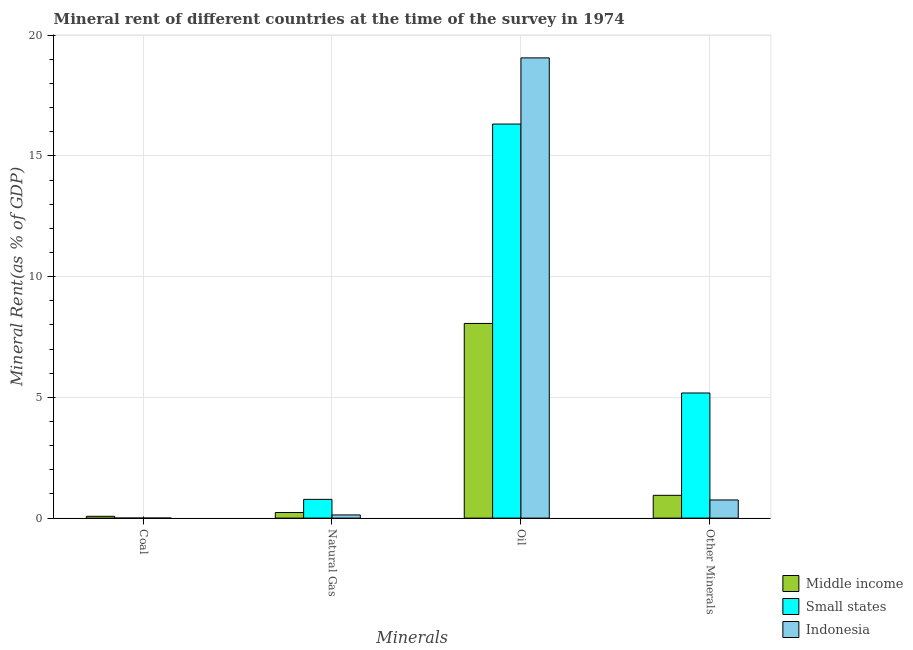How many groups of bars are there?
Your answer should be compact. 4. Are the number of bars per tick equal to the number of legend labels?
Your answer should be compact. Yes. Are the number of bars on each tick of the X-axis equal?
Your answer should be very brief. Yes. How many bars are there on the 2nd tick from the left?
Your answer should be compact. 3. How many bars are there on the 1st tick from the right?
Provide a short and direct response. 3. What is the label of the 1st group of bars from the left?
Offer a terse response. Coal. What is the  rent of other minerals in Indonesia?
Your response must be concise. 0.75. Across all countries, what is the maximum coal rent?
Provide a succinct answer. 0.08. Across all countries, what is the minimum natural gas rent?
Your answer should be very brief. 0.13. What is the total oil rent in the graph?
Keep it short and to the point. 43.45. What is the difference between the natural gas rent in Indonesia and that in Middle income?
Make the answer very short. -0.1. What is the difference between the oil rent in Indonesia and the coal rent in Middle income?
Provide a short and direct response. 18.99. What is the average oil rent per country?
Offer a very short reply. 14.48. What is the difference between the coal rent and oil rent in Middle income?
Provide a succinct answer. -7.99. In how many countries, is the natural gas rent greater than 9 %?
Keep it short and to the point. 0. What is the ratio of the oil rent in Small states to that in Indonesia?
Offer a terse response. 0.86. Is the natural gas rent in Small states less than that in Indonesia?
Your answer should be very brief. No. What is the difference between the highest and the second highest natural gas rent?
Provide a short and direct response. 0.54. What is the difference between the highest and the lowest coal rent?
Offer a very short reply. 0.07. Is the sum of the coal rent in Indonesia and Small states greater than the maximum oil rent across all countries?
Provide a succinct answer. No. Is it the case that in every country, the sum of the natural gas rent and oil rent is greater than the sum of  rent of other minerals and coal rent?
Offer a terse response. Yes. What does the 3rd bar from the left in Oil represents?
Offer a terse response. Indonesia. What does the 1st bar from the right in Natural Gas represents?
Make the answer very short. Indonesia. Is it the case that in every country, the sum of the coal rent and natural gas rent is greater than the oil rent?
Your response must be concise. No. How many bars are there?
Give a very brief answer. 12. Are all the bars in the graph horizontal?
Provide a short and direct response. No. How many countries are there in the graph?
Offer a terse response. 3. Does the graph contain grids?
Ensure brevity in your answer.  Yes. How many legend labels are there?
Offer a terse response. 3. What is the title of the graph?
Keep it short and to the point. Mineral rent of different countries at the time of the survey in 1974. What is the label or title of the X-axis?
Provide a short and direct response. Minerals. What is the label or title of the Y-axis?
Your answer should be very brief. Mineral Rent(as % of GDP). What is the Mineral Rent(as % of GDP) of Middle income in Coal?
Ensure brevity in your answer.  0.08. What is the Mineral Rent(as % of GDP) of Small states in Coal?
Your answer should be very brief. 0. What is the Mineral Rent(as % of GDP) in Indonesia in Coal?
Offer a very short reply. 0. What is the Mineral Rent(as % of GDP) in Middle income in Natural Gas?
Give a very brief answer. 0.23. What is the Mineral Rent(as % of GDP) of Small states in Natural Gas?
Make the answer very short. 0.78. What is the Mineral Rent(as % of GDP) in Indonesia in Natural Gas?
Your response must be concise. 0.13. What is the Mineral Rent(as % of GDP) in Middle income in Oil?
Offer a terse response. 8.06. What is the Mineral Rent(as % of GDP) in Small states in Oil?
Provide a short and direct response. 16.32. What is the Mineral Rent(as % of GDP) in Indonesia in Oil?
Give a very brief answer. 19.06. What is the Mineral Rent(as % of GDP) of Middle income in Other Minerals?
Offer a very short reply. 0.94. What is the Mineral Rent(as % of GDP) of Small states in Other Minerals?
Provide a short and direct response. 5.18. What is the Mineral Rent(as % of GDP) in Indonesia in Other Minerals?
Your answer should be compact. 0.75. Across all Minerals, what is the maximum Mineral Rent(as % of GDP) of Middle income?
Your response must be concise. 8.06. Across all Minerals, what is the maximum Mineral Rent(as % of GDP) of Small states?
Your response must be concise. 16.32. Across all Minerals, what is the maximum Mineral Rent(as % of GDP) of Indonesia?
Keep it short and to the point. 19.06. Across all Minerals, what is the minimum Mineral Rent(as % of GDP) in Middle income?
Offer a terse response. 0.08. Across all Minerals, what is the minimum Mineral Rent(as % of GDP) of Small states?
Your response must be concise. 0. Across all Minerals, what is the minimum Mineral Rent(as % of GDP) of Indonesia?
Provide a short and direct response. 0. What is the total Mineral Rent(as % of GDP) in Middle income in the graph?
Give a very brief answer. 9.31. What is the total Mineral Rent(as % of GDP) in Small states in the graph?
Provide a short and direct response. 22.28. What is the total Mineral Rent(as % of GDP) in Indonesia in the graph?
Offer a terse response. 19.95. What is the difference between the Mineral Rent(as % of GDP) in Middle income in Coal and that in Natural Gas?
Provide a short and direct response. -0.16. What is the difference between the Mineral Rent(as % of GDP) of Small states in Coal and that in Natural Gas?
Give a very brief answer. -0.78. What is the difference between the Mineral Rent(as % of GDP) in Indonesia in Coal and that in Natural Gas?
Your answer should be very brief. -0.13. What is the difference between the Mineral Rent(as % of GDP) in Middle income in Coal and that in Oil?
Your answer should be compact. -7.99. What is the difference between the Mineral Rent(as % of GDP) of Small states in Coal and that in Oil?
Provide a short and direct response. -16.32. What is the difference between the Mineral Rent(as % of GDP) in Indonesia in Coal and that in Oil?
Provide a succinct answer. -19.06. What is the difference between the Mineral Rent(as % of GDP) of Middle income in Coal and that in Other Minerals?
Make the answer very short. -0.87. What is the difference between the Mineral Rent(as % of GDP) of Small states in Coal and that in Other Minerals?
Offer a terse response. -5.18. What is the difference between the Mineral Rent(as % of GDP) in Indonesia in Coal and that in Other Minerals?
Give a very brief answer. -0.75. What is the difference between the Mineral Rent(as % of GDP) of Middle income in Natural Gas and that in Oil?
Keep it short and to the point. -7.83. What is the difference between the Mineral Rent(as % of GDP) of Small states in Natural Gas and that in Oil?
Give a very brief answer. -15.54. What is the difference between the Mineral Rent(as % of GDP) of Indonesia in Natural Gas and that in Oil?
Provide a succinct answer. -18.93. What is the difference between the Mineral Rent(as % of GDP) in Middle income in Natural Gas and that in Other Minerals?
Give a very brief answer. -0.71. What is the difference between the Mineral Rent(as % of GDP) in Small states in Natural Gas and that in Other Minerals?
Offer a very short reply. -4.41. What is the difference between the Mineral Rent(as % of GDP) of Indonesia in Natural Gas and that in Other Minerals?
Your answer should be very brief. -0.62. What is the difference between the Mineral Rent(as % of GDP) of Middle income in Oil and that in Other Minerals?
Provide a succinct answer. 7.12. What is the difference between the Mineral Rent(as % of GDP) in Small states in Oil and that in Other Minerals?
Provide a short and direct response. 11.14. What is the difference between the Mineral Rent(as % of GDP) of Indonesia in Oil and that in Other Minerals?
Your answer should be very brief. 18.31. What is the difference between the Mineral Rent(as % of GDP) in Middle income in Coal and the Mineral Rent(as % of GDP) in Small states in Natural Gas?
Your answer should be compact. -0.7. What is the difference between the Mineral Rent(as % of GDP) of Middle income in Coal and the Mineral Rent(as % of GDP) of Indonesia in Natural Gas?
Your answer should be compact. -0.06. What is the difference between the Mineral Rent(as % of GDP) of Small states in Coal and the Mineral Rent(as % of GDP) of Indonesia in Natural Gas?
Provide a succinct answer. -0.13. What is the difference between the Mineral Rent(as % of GDP) of Middle income in Coal and the Mineral Rent(as % of GDP) of Small states in Oil?
Your answer should be compact. -16.25. What is the difference between the Mineral Rent(as % of GDP) of Middle income in Coal and the Mineral Rent(as % of GDP) of Indonesia in Oil?
Your answer should be compact. -18.99. What is the difference between the Mineral Rent(as % of GDP) in Small states in Coal and the Mineral Rent(as % of GDP) in Indonesia in Oil?
Your answer should be very brief. -19.06. What is the difference between the Mineral Rent(as % of GDP) of Middle income in Coal and the Mineral Rent(as % of GDP) of Small states in Other Minerals?
Your answer should be very brief. -5.11. What is the difference between the Mineral Rent(as % of GDP) of Middle income in Coal and the Mineral Rent(as % of GDP) of Indonesia in Other Minerals?
Provide a short and direct response. -0.68. What is the difference between the Mineral Rent(as % of GDP) of Small states in Coal and the Mineral Rent(as % of GDP) of Indonesia in Other Minerals?
Offer a terse response. -0.75. What is the difference between the Mineral Rent(as % of GDP) in Middle income in Natural Gas and the Mineral Rent(as % of GDP) in Small states in Oil?
Ensure brevity in your answer.  -16.09. What is the difference between the Mineral Rent(as % of GDP) of Middle income in Natural Gas and the Mineral Rent(as % of GDP) of Indonesia in Oil?
Your answer should be very brief. -18.83. What is the difference between the Mineral Rent(as % of GDP) of Small states in Natural Gas and the Mineral Rent(as % of GDP) of Indonesia in Oil?
Your answer should be compact. -18.29. What is the difference between the Mineral Rent(as % of GDP) in Middle income in Natural Gas and the Mineral Rent(as % of GDP) in Small states in Other Minerals?
Your answer should be compact. -4.95. What is the difference between the Mineral Rent(as % of GDP) in Middle income in Natural Gas and the Mineral Rent(as % of GDP) in Indonesia in Other Minerals?
Your answer should be compact. -0.52. What is the difference between the Mineral Rent(as % of GDP) in Small states in Natural Gas and the Mineral Rent(as % of GDP) in Indonesia in Other Minerals?
Offer a terse response. 0.02. What is the difference between the Mineral Rent(as % of GDP) in Middle income in Oil and the Mineral Rent(as % of GDP) in Small states in Other Minerals?
Give a very brief answer. 2.88. What is the difference between the Mineral Rent(as % of GDP) in Middle income in Oil and the Mineral Rent(as % of GDP) in Indonesia in Other Minerals?
Keep it short and to the point. 7.31. What is the difference between the Mineral Rent(as % of GDP) of Small states in Oil and the Mineral Rent(as % of GDP) of Indonesia in Other Minerals?
Your answer should be compact. 15.57. What is the average Mineral Rent(as % of GDP) in Middle income per Minerals?
Offer a very short reply. 2.33. What is the average Mineral Rent(as % of GDP) of Small states per Minerals?
Offer a terse response. 5.57. What is the average Mineral Rent(as % of GDP) of Indonesia per Minerals?
Ensure brevity in your answer.  4.99. What is the difference between the Mineral Rent(as % of GDP) of Middle income and Mineral Rent(as % of GDP) of Small states in Coal?
Provide a short and direct response. 0.07. What is the difference between the Mineral Rent(as % of GDP) in Middle income and Mineral Rent(as % of GDP) in Indonesia in Coal?
Offer a very short reply. 0.07. What is the difference between the Mineral Rent(as % of GDP) of Small states and Mineral Rent(as % of GDP) of Indonesia in Coal?
Give a very brief answer. -0. What is the difference between the Mineral Rent(as % of GDP) of Middle income and Mineral Rent(as % of GDP) of Small states in Natural Gas?
Ensure brevity in your answer.  -0.54. What is the difference between the Mineral Rent(as % of GDP) of Middle income and Mineral Rent(as % of GDP) of Indonesia in Natural Gas?
Your answer should be compact. 0.1. What is the difference between the Mineral Rent(as % of GDP) of Small states and Mineral Rent(as % of GDP) of Indonesia in Natural Gas?
Your answer should be compact. 0.64. What is the difference between the Mineral Rent(as % of GDP) in Middle income and Mineral Rent(as % of GDP) in Small states in Oil?
Your answer should be compact. -8.26. What is the difference between the Mineral Rent(as % of GDP) in Middle income and Mineral Rent(as % of GDP) in Indonesia in Oil?
Your response must be concise. -11. What is the difference between the Mineral Rent(as % of GDP) of Small states and Mineral Rent(as % of GDP) of Indonesia in Oil?
Provide a short and direct response. -2.74. What is the difference between the Mineral Rent(as % of GDP) of Middle income and Mineral Rent(as % of GDP) of Small states in Other Minerals?
Your answer should be very brief. -4.24. What is the difference between the Mineral Rent(as % of GDP) of Middle income and Mineral Rent(as % of GDP) of Indonesia in Other Minerals?
Your response must be concise. 0.19. What is the difference between the Mineral Rent(as % of GDP) of Small states and Mineral Rent(as % of GDP) of Indonesia in Other Minerals?
Offer a very short reply. 4.43. What is the ratio of the Mineral Rent(as % of GDP) of Middle income in Coal to that in Natural Gas?
Your response must be concise. 0.33. What is the ratio of the Mineral Rent(as % of GDP) of Small states in Coal to that in Natural Gas?
Provide a succinct answer. 0. What is the ratio of the Mineral Rent(as % of GDP) of Indonesia in Coal to that in Natural Gas?
Provide a short and direct response. 0.01. What is the ratio of the Mineral Rent(as % of GDP) of Middle income in Coal to that in Oil?
Give a very brief answer. 0.01. What is the ratio of the Mineral Rent(as % of GDP) of Indonesia in Coal to that in Oil?
Your answer should be compact. 0. What is the ratio of the Mineral Rent(as % of GDP) of Middle income in Coal to that in Other Minerals?
Offer a terse response. 0.08. What is the ratio of the Mineral Rent(as % of GDP) in Small states in Coal to that in Other Minerals?
Offer a very short reply. 0. What is the ratio of the Mineral Rent(as % of GDP) of Indonesia in Coal to that in Other Minerals?
Give a very brief answer. 0. What is the ratio of the Mineral Rent(as % of GDP) in Middle income in Natural Gas to that in Oil?
Make the answer very short. 0.03. What is the ratio of the Mineral Rent(as % of GDP) in Small states in Natural Gas to that in Oil?
Offer a terse response. 0.05. What is the ratio of the Mineral Rent(as % of GDP) of Indonesia in Natural Gas to that in Oil?
Provide a succinct answer. 0.01. What is the ratio of the Mineral Rent(as % of GDP) of Middle income in Natural Gas to that in Other Minerals?
Ensure brevity in your answer.  0.25. What is the ratio of the Mineral Rent(as % of GDP) of Small states in Natural Gas to that in Other Minerals?
Offer a very short reply. 0.15. What is the ratio of the Mineral Rent(as % of GDP) in Indonesia in Natural Gas to that in Other Minerals?
Make the answer very short. 0.18. What is the ratio of the Mineral Rent(as % of GDP) in Middle income in Oil to that in Other Minerals?
Offer a very short reply. 8.54. What is the ratio of the Mineral Rent(as % of GDP) of Small states in Oil to that in Other Minerals?
Make the answer very short. 3.15. What is the ratio of the Mineral Rent(as % of GDP) in Indonesia in Oil to that in Other Minerals?
Ensure brevity in your answer.  25.34. What is the difference between the highest and the second highest Mineral Rent(as % of GDP) in Middle income?
Offer a very short reply. 7.12. What is the difference between the highest and the second highest Mineral Rent(as % of GDP) of Small states?
Give a very brief answer. 11.14. What is the difference between the highest and the second highest Mineral Rent(as % of GDP) of Indonesia?
Offer a terse response. 18.31. What is the difference between the highest and the lowest Mineral Rent(as % of GDP) of Middle income?
Ensure brevity in your answer.  7.99. What is the difference between the highest and the lowest Mineral Rent(as % of GDP) in Small states?
Make the answer very short. 16.32. What is the difference between the highest and the lowest Mineral Rent(as % of GDP) in Indonesia?
Your answer should be compact. 19.06. 